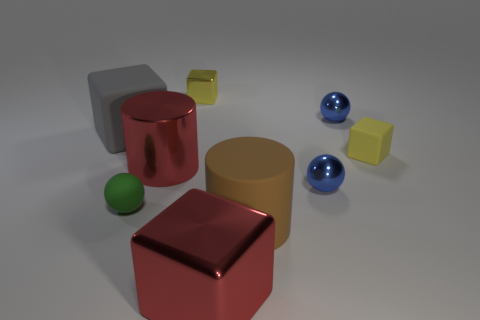There is a object that is the same color as the large metal cube; what is its size?
Offer a terse response. Large. There is a small green object; does it have the same shape as the small blue metal object in front of the large gray matte block?
Provide a short and direct response. Yes. There is a big metal object behind the brown rubber object; does it have the same shape as the brown thing?
Ensure brevity in your answer.  Yes. How many shiny objects are both in front of the small metallic cube and on the left side of the red cube?
Provide a succinct answer. 1. What number of other things are the same size as the green rubber thing?
Make the answer very short. 4. Are there the same number of large red shiny objects in front of the big metal cube and small matte things?
Offer a terse response. No. There is a metallic block to the left of the large red cube; does it have the same color as the rubber block that is in front of the gray matte thing?
Your answer should be compact. Yes. What is the material of the large thing that is both behind the large red cube and right of the red cylinder?
Provide a short and direct response. Rubber. The large rubber cylinder is what color?
Your answer should be compact. Brown. What number of other things are the same shape as the green rubber object?
Provide a succinct answer. 2. 